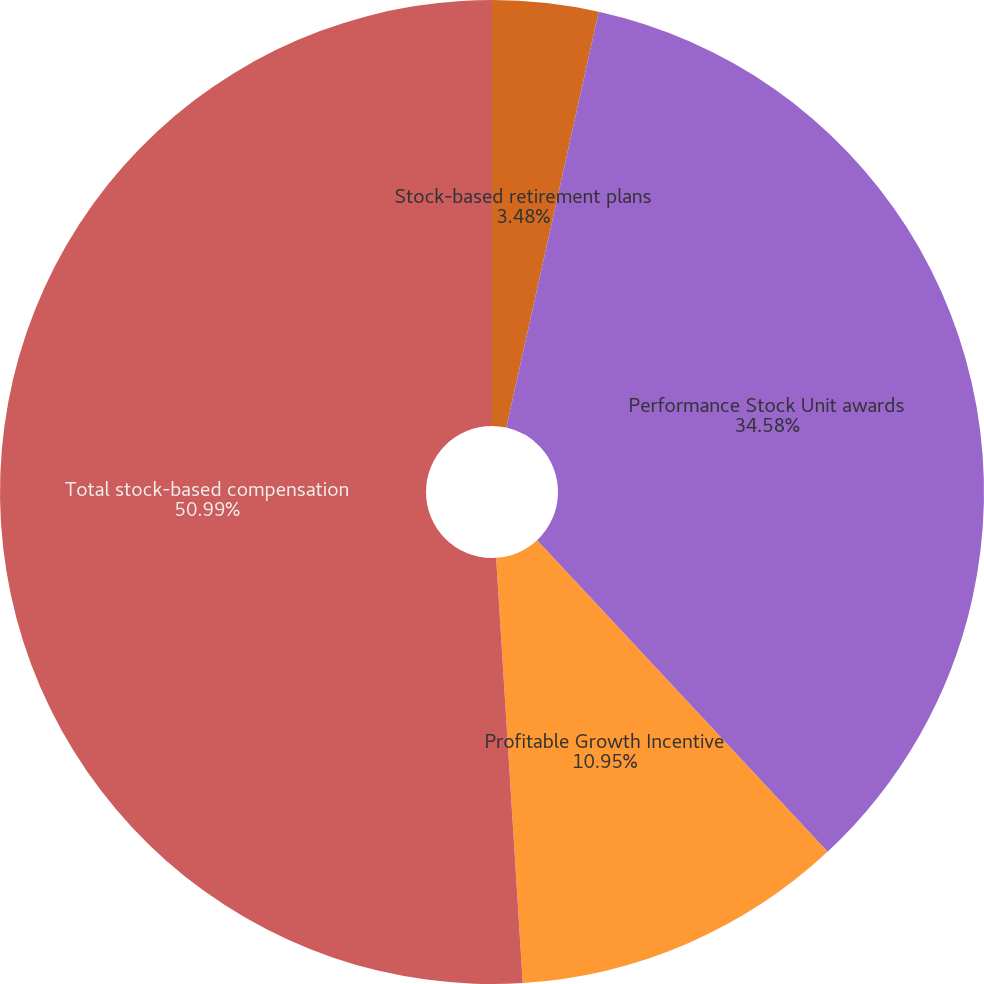<chart> <loc_0><loc_0><loc_500><loc_500><pie_chart><fcel>Stock-based retirement plans<fcel>Performance Stock Unit awards<fcel>Profitable Growth Incentive<fcel>Total stock-based compensation<nl><fcel>3.48%<fcel>34.58%<fcel>10.95%<fcel>51.0%<nl></chart> 